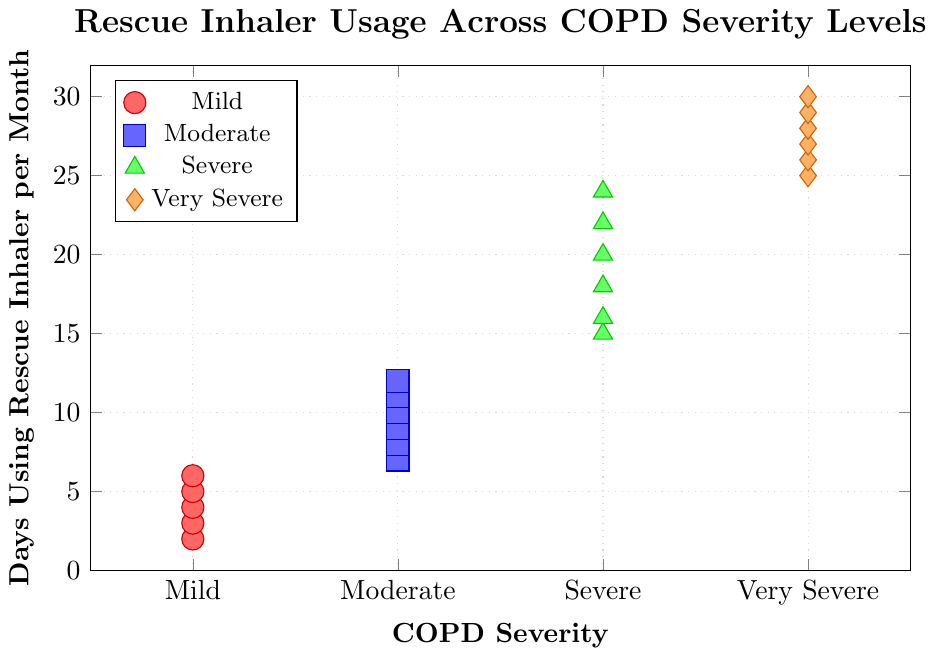what's the average number of days using a rescue inhaler for patients with Severe COPD? Identify and sum up the data points for Severe COPD: (15 + 16 + 18 + 20 + 22 + 24) = 115. There are 6 data points, so the average is 115 / 6 ≈ 19.2
Answer: 19.2 which severity level has the highest median number of days using a rescue inhaler? Look at each severity level and identify the median values. For Mild: 4, for Moderate: 9, for Severe: 18, and for Very Severe: 27. Very Severe has the highest median value.
Answer: Very Severe are there any severity levels with overlapping days using a rescue inhaler? Compare the number of days reported across different severity levels to see if they share any common values. There are no overlapping days between the severity levels. Each level has distinct values.
Answer: No what is the range of days using a rescue inhaler for Moderate COPD patients? Identify the minimum and maximum values for Moderate COPD: min is 7 and max is 12. Calculate the range: 12 - 7 = 5.
Answer: 5 which category has the most varied rescue inhaler usage? Determine the range of days for each category: Mild (2 to 6 - range 4), Moderate (7 to 12 - range 5), Severe (15 to 24 - range 9), Very Severe (25 to 30 - range 5). Severe COPD has the largest range, indicating the most varied usage.
Answer: Severe how many patients report using rescue inhalers for more than 20 days a month? Count the data points where days > 20. These are 22, 24, 25, 26, 27, 28, 29, and 30. There are 8 such data points.
Answer: 8 is the average number of days using a rescue inhaler higher in Severe or Very Severe COPD patients? Calculate the averages again for Severe (19.2) and Very Severe (27.5). Compare the two values. The average is higher in Very Severe COPD patients.
Answer: Very Severe 